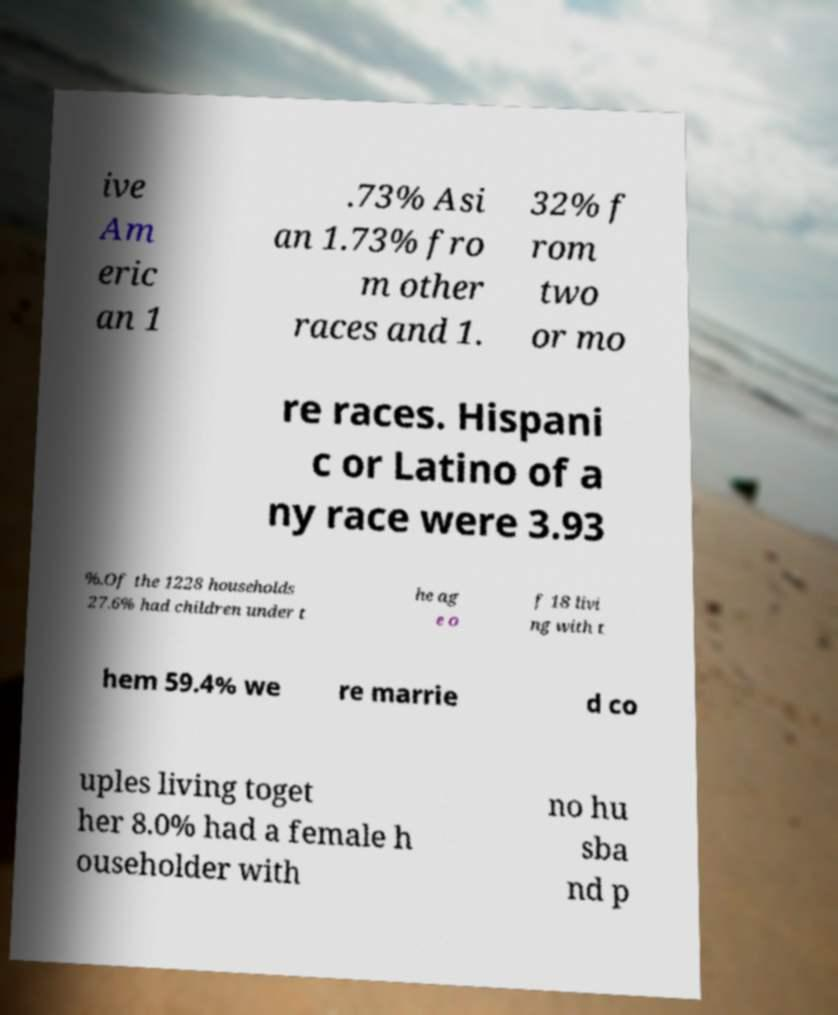Can you accurately transcribe the text from the provided image for me? ive Am eric an 1 .73% Asi an 1.73% fro m other races and 1. 32% f rom two or mo re races. Hispani c or Latino of a ny race were 3.93 %.Of the 1228 households 27.6% had children under t he ag e o f 18 livi ng with t hem 59.4% we re marrie d co uples living toget her 8.0% had a female h ouseholder with no hu sba nd p 